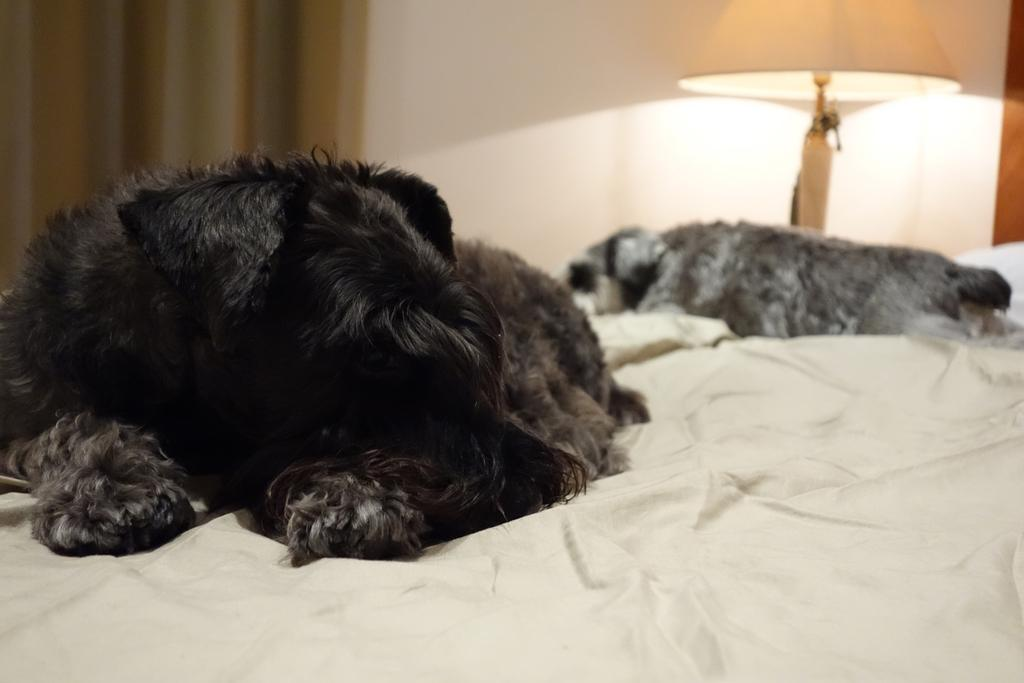What is the number of animals present in the image? There are two animals in the image. What are the animals doing in the image? The animals are laying on a bed. What can be seen in the background of the image? There is a lamp and a curtain associated with a wall in the background of the image. What is the distance between the giraffe and the air in the image? There is no giraffe present in the image, and the concept of "air" is not applicable in this context. The image features two animals laying on a bed, and the background elements include a lamp and a curtain associated with a wall. 